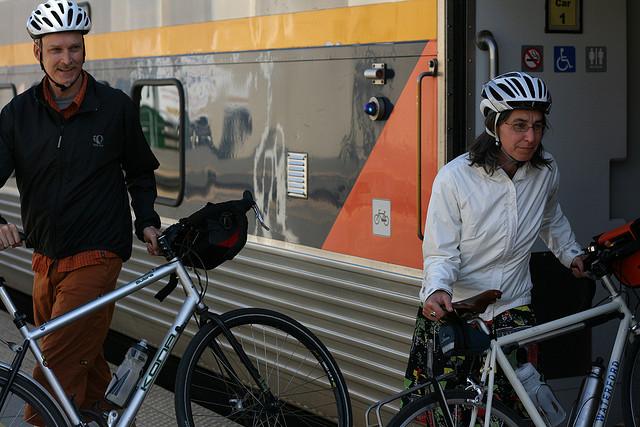What do the signs above the woman's head mean?
Answer briefly. No smoking. What is the symbol on the door?
Be succinct. Bicycle. How many bikes are in the photo?
Answer briefly. 2. Do these people appear to be having fun?
Give a very brief answer. Yes. Why are the people wearing helmets?
Keep it brief. Protection. 